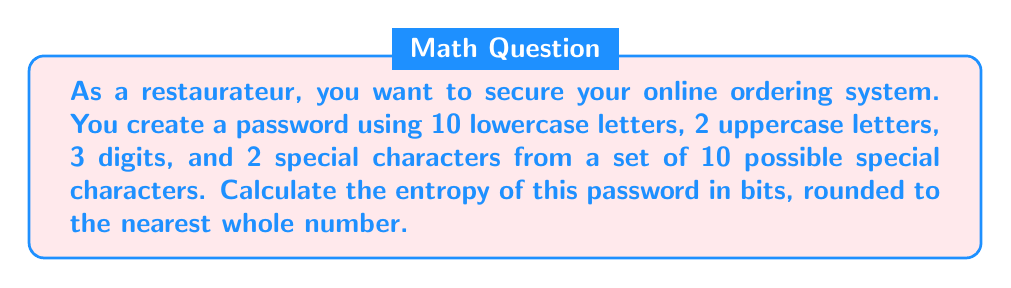Provide a solution to this math problem. To calculate the password entropy, we need to follow these steps:

1. Determine the total number of possible characters:
   - Lowercase letters: 26
   - Uppercase letters: 26
   - Digits: 10
   - Special characters: 10

2. Calculate the total number of possible combinations:
   $$N = 26^{10} \times 26^2 \times 10^3 \times 10^2$$

3. Calculate the entropy using the formula:
   $$H = \log_2(N)$$

4. Substitute the values:
   $$H = \log_2(26^{10} \times 26^2 \times 10^3 \times 10^2)$$

5. Use logarithm properties to simplify:
   $$H = 10 \log_2(26) + 2 \log_2(26) + 3 \log_2(10) + 2 \log_2(10)$$

6. Calculate:
   $$H = 10 \times 4.7004 + 2 \times 4.7004 + 3 \times 3.3219 + 2 \times 3.3219$$
   $$H = 47.004 + 9.4008 + 9.9657 + 6.6438$$
   $$H = 73.0143$$

7. Round to the nearest whole number:
   $$H \approx 73$$

Therefore, the entropy of the password is approximately 73 bits.
Answer: 73 bits 